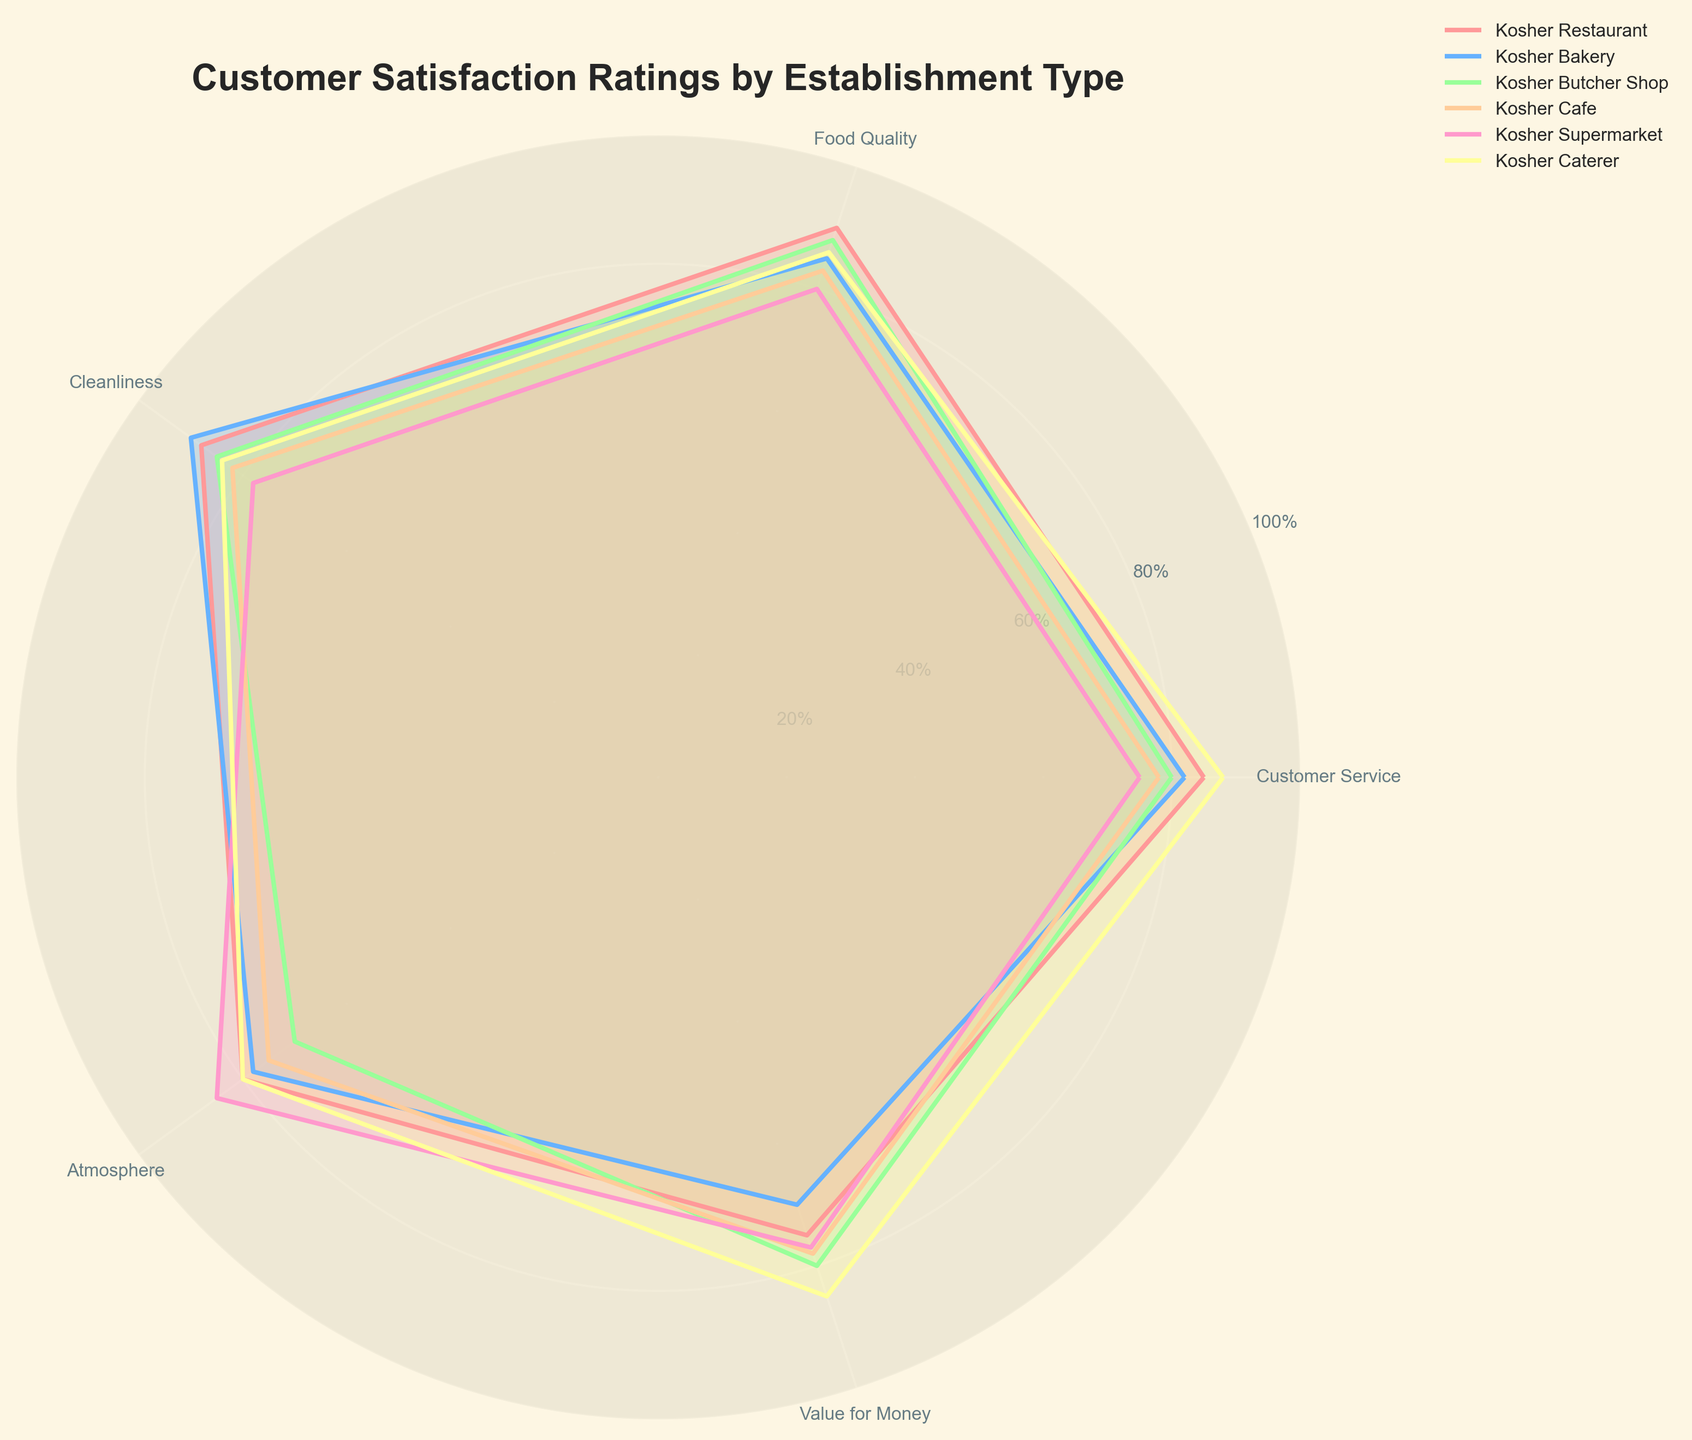What is the title of the radar chart? The title is usually prominently displayed at the top of the radar chart in a larger or bold font to summarize what the chart is about.
Answer: Customer Satisfaction Ratings by Establishment Type Which establishment type has the highest customer service rating? Look at the radial lines for each establishment type and identify the one that extends furthest to the "Customer Service" label.
Answer: Kosher Caterer How does the cleanliness rating of Kosher Bakery compare to that of Kosher Supermarket? Identify the radial lines corresponding to "Cleanliness" for both Kosher Bakery and Kosher Supermarket and compare their lengths.
Answer: Kosher Bakery is higher Which establishment type has the lowest rating in food quality? Check the radial lines associated with "Food Quality" and find the establishment with the shortest line.
Answer: Kosher Supermarket What is the average value for money rating across all establishment types? Extract the value for money ratings for all establishments (75, 70, 80, 78, 77, 85), then compute the average: (75 + 70 + 80 + 78 + 77 + 85) / 6.
Answer: 77.5 Which two establishment types have the most similar atmosphere ratings? Identify and compare the radial lines for "Atmosphere" for each establishment type to find the closest ones.
Answer: Kosher Restaurant and Kosher Caterer How does the customer service rating of Kosher Cafe compare to that of Kosher Restaurant? Locate the radial lines for "Customer Service" for both Kosher Cafe and Kosher Restaurant and observe which is longer.
Answer: Kosher Cafe is lower What is the difference between the highest and lowest customer service ratings? Identify the highest and lowest customer service ratings (88 for Kosher Caterer and 75 for Kosher Supermarket), then compute the difference: 88 - 75.
Answer: 13 Which establishment type has the most balanced ratings across all categories? Identify the radar chart lines that form the most symmetrical shape, indicating similar ratings across all categories.
Answer: Kosher Caterer What is the sum of the cleanliness ratings for Kosher Restaurant, Kosher Bakery, and Kosher Butcher Shop? Add up the cleanliness ratings for these three establishment types: 88 + 90 + 85.
Answer: 263 